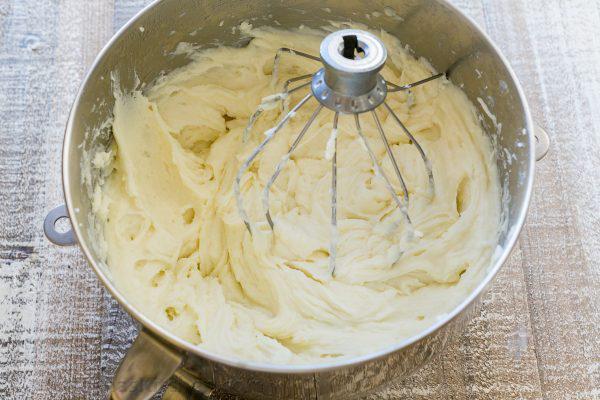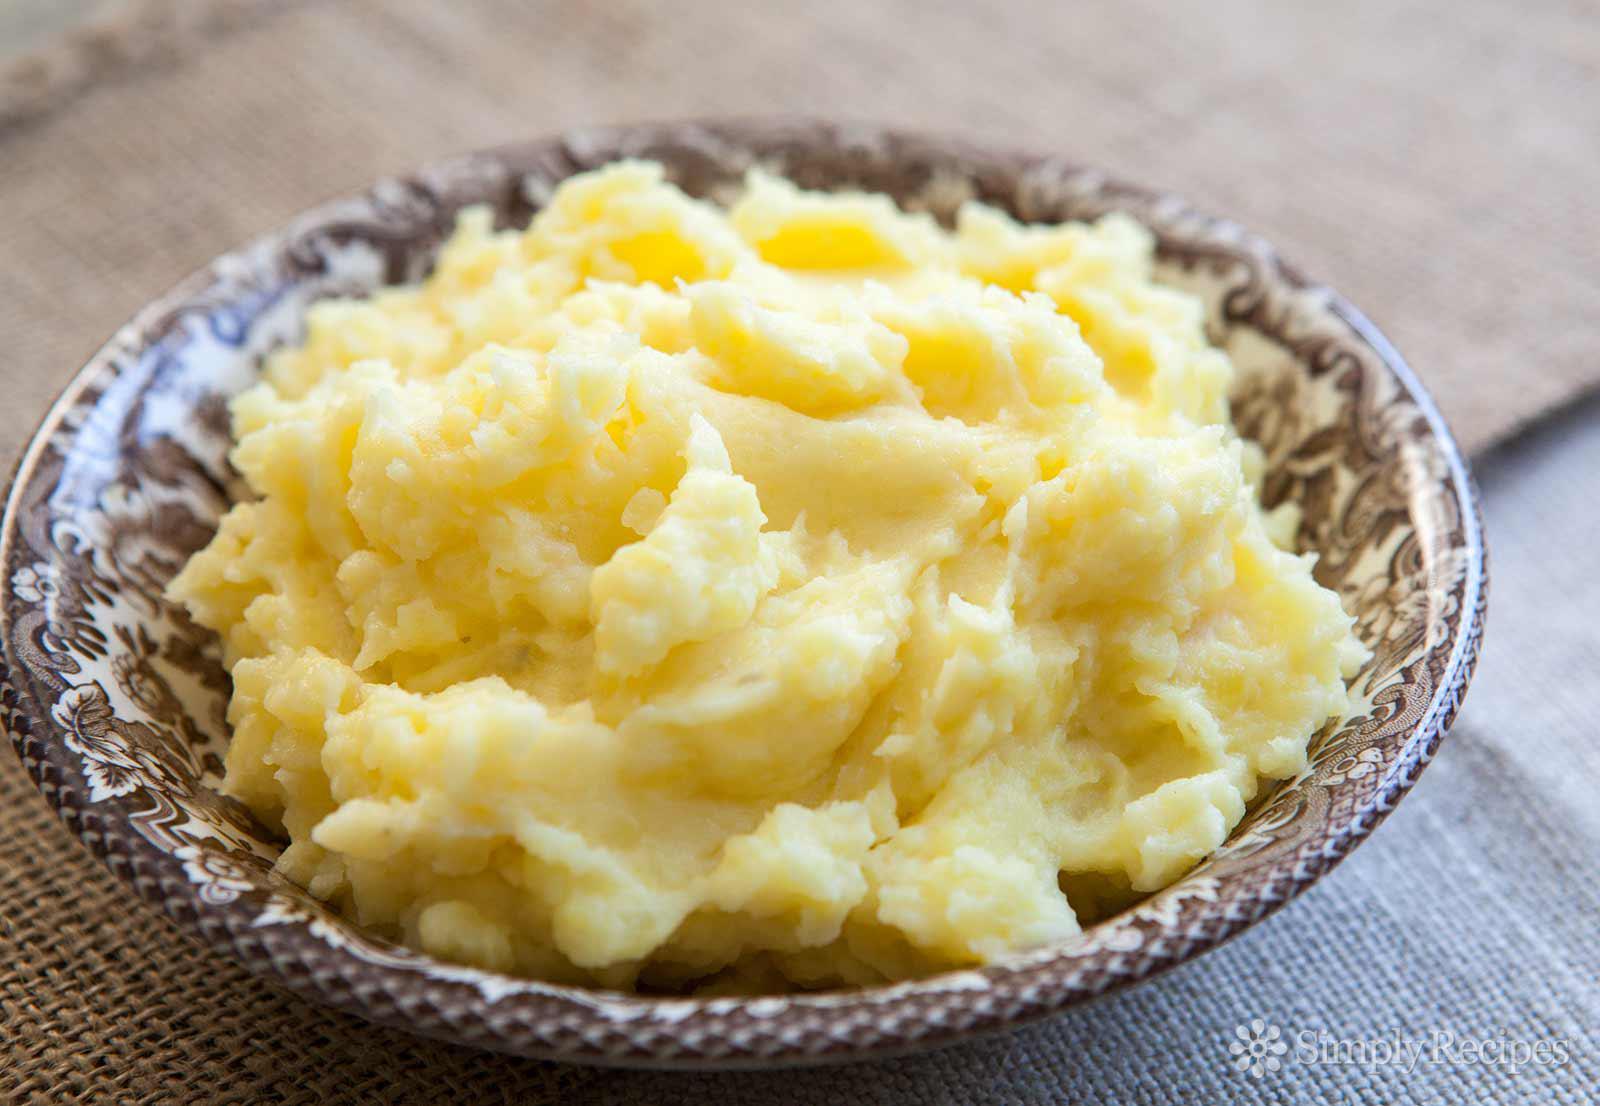The first image is the image on the left, the second image is the image on the right. Assess this claim about the two images: "One image features a bowl of potatoes with a spoon in the food.". Correct or not? Answer yes or no. No. The first image is the image on the left, the second image is the image on the right. For the images displayed, is the sentence "A spoon sits in a bowl of potatoes in one of the images." factually correct? Answer yes or no. No. 